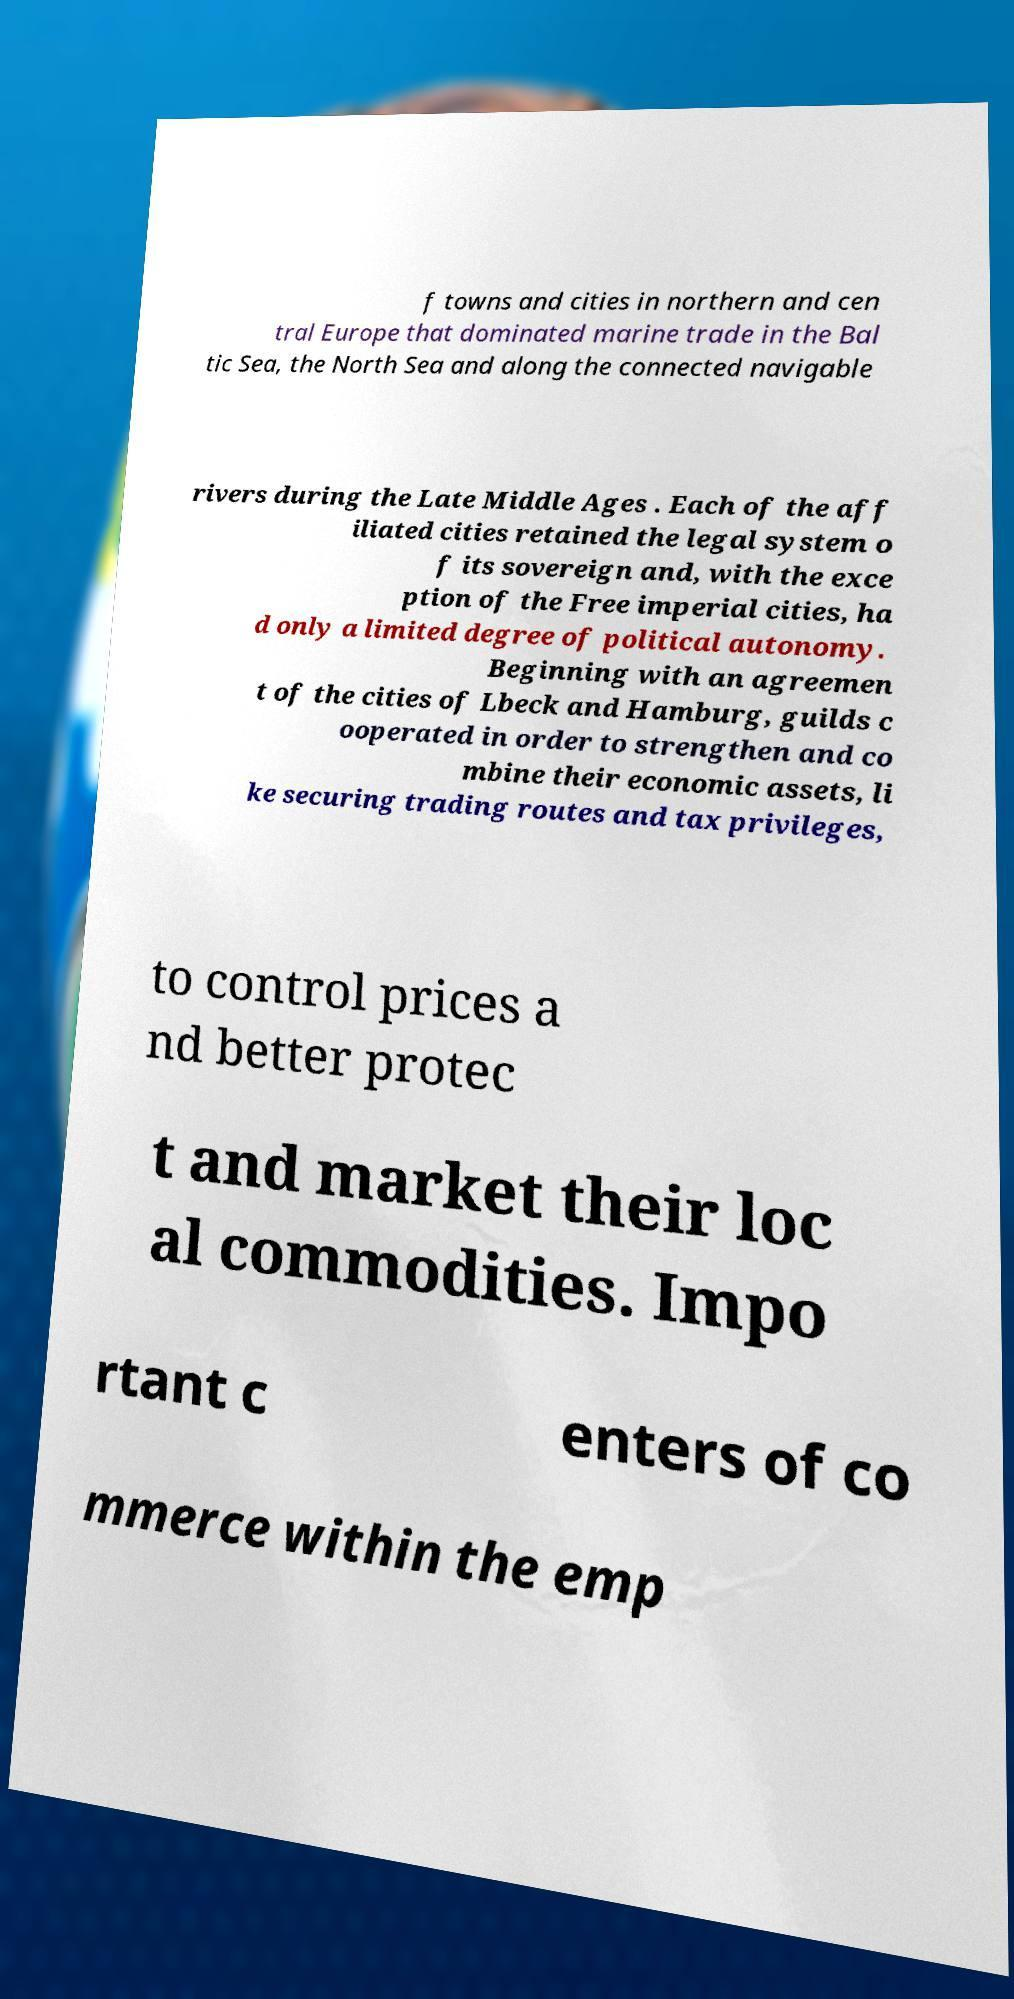Please identify and transcribe the text found in this image. f towns and cities in northern and cen tral Europe that dominated marine trade in the Bal tic Sea, the North Sea and along the connected navigable rivers during the Late Middle Ages . Each of the aff iliated cities retained the legal system o f its sovereign and, with the exce ption of the Free imperial cities, ha d only a limited degree of political autonomy. Beginning with an agreemen t of the cities of Lbeck and Hamburg, guilds c ooperated in order to strengthen and co mbine their economic assets, li ke securing trading routes and tax privileges, to control prices a nd better protec t and market their loc al commodities. Impo rtant c enters of co mmerce within the emp 